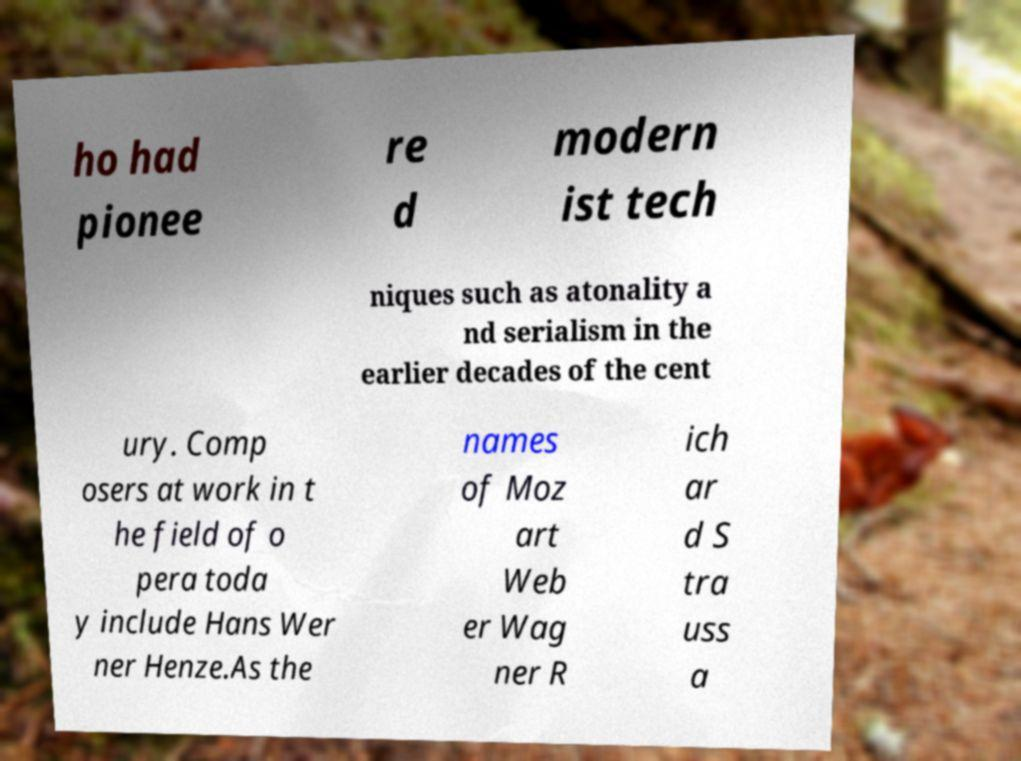There's text embedded in this image that I need extracted. Can you transcribe it verbatim? ho had pionee re d modern ist tech niques such as atonality a nd serialism in the earlier decades of the cent ury. Comp osers at work in t he field of o pera toda y include Hans Wer ner Henze.As the names of Moz art Web er Wag ner R ich ar d S tra uss a 